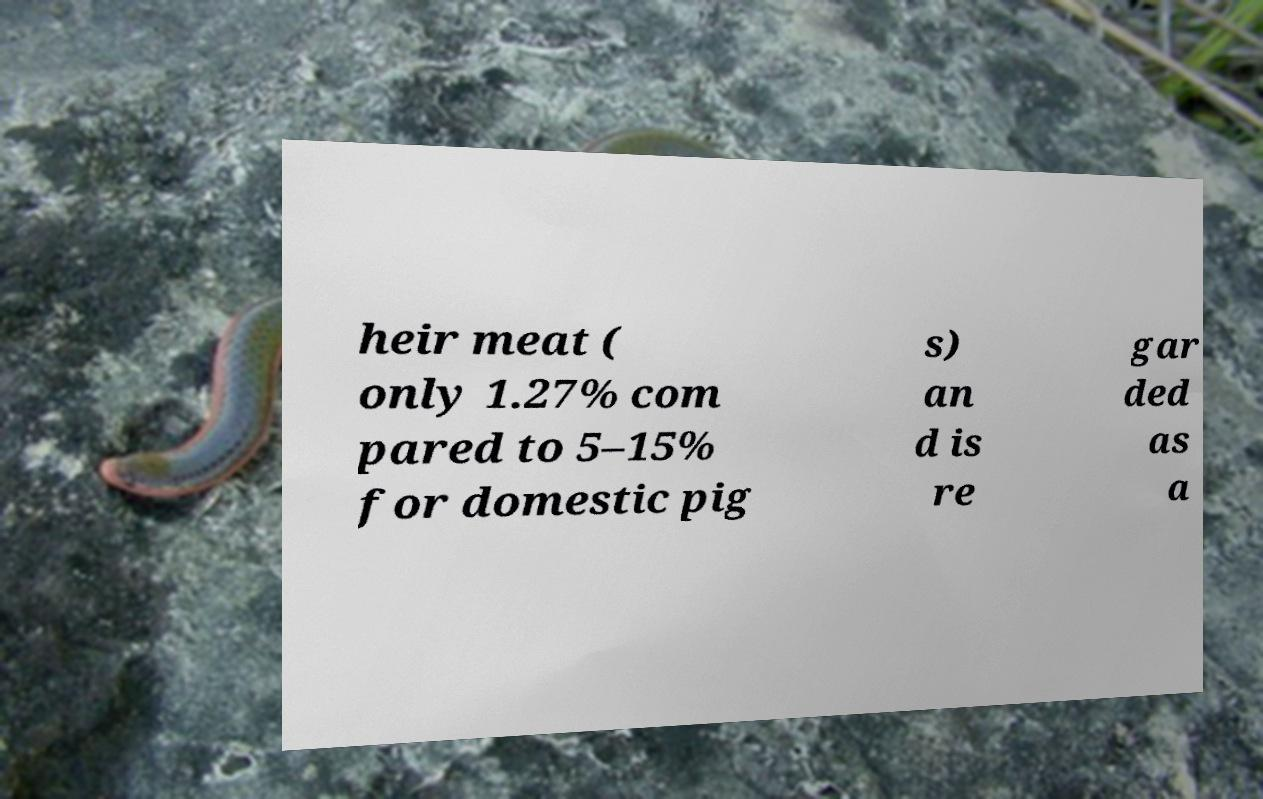Could you extract and type out the text from this image? heir meat ( only 1.27% com pared to 5–15% for domestic pig s) an d is re gar ded as a 